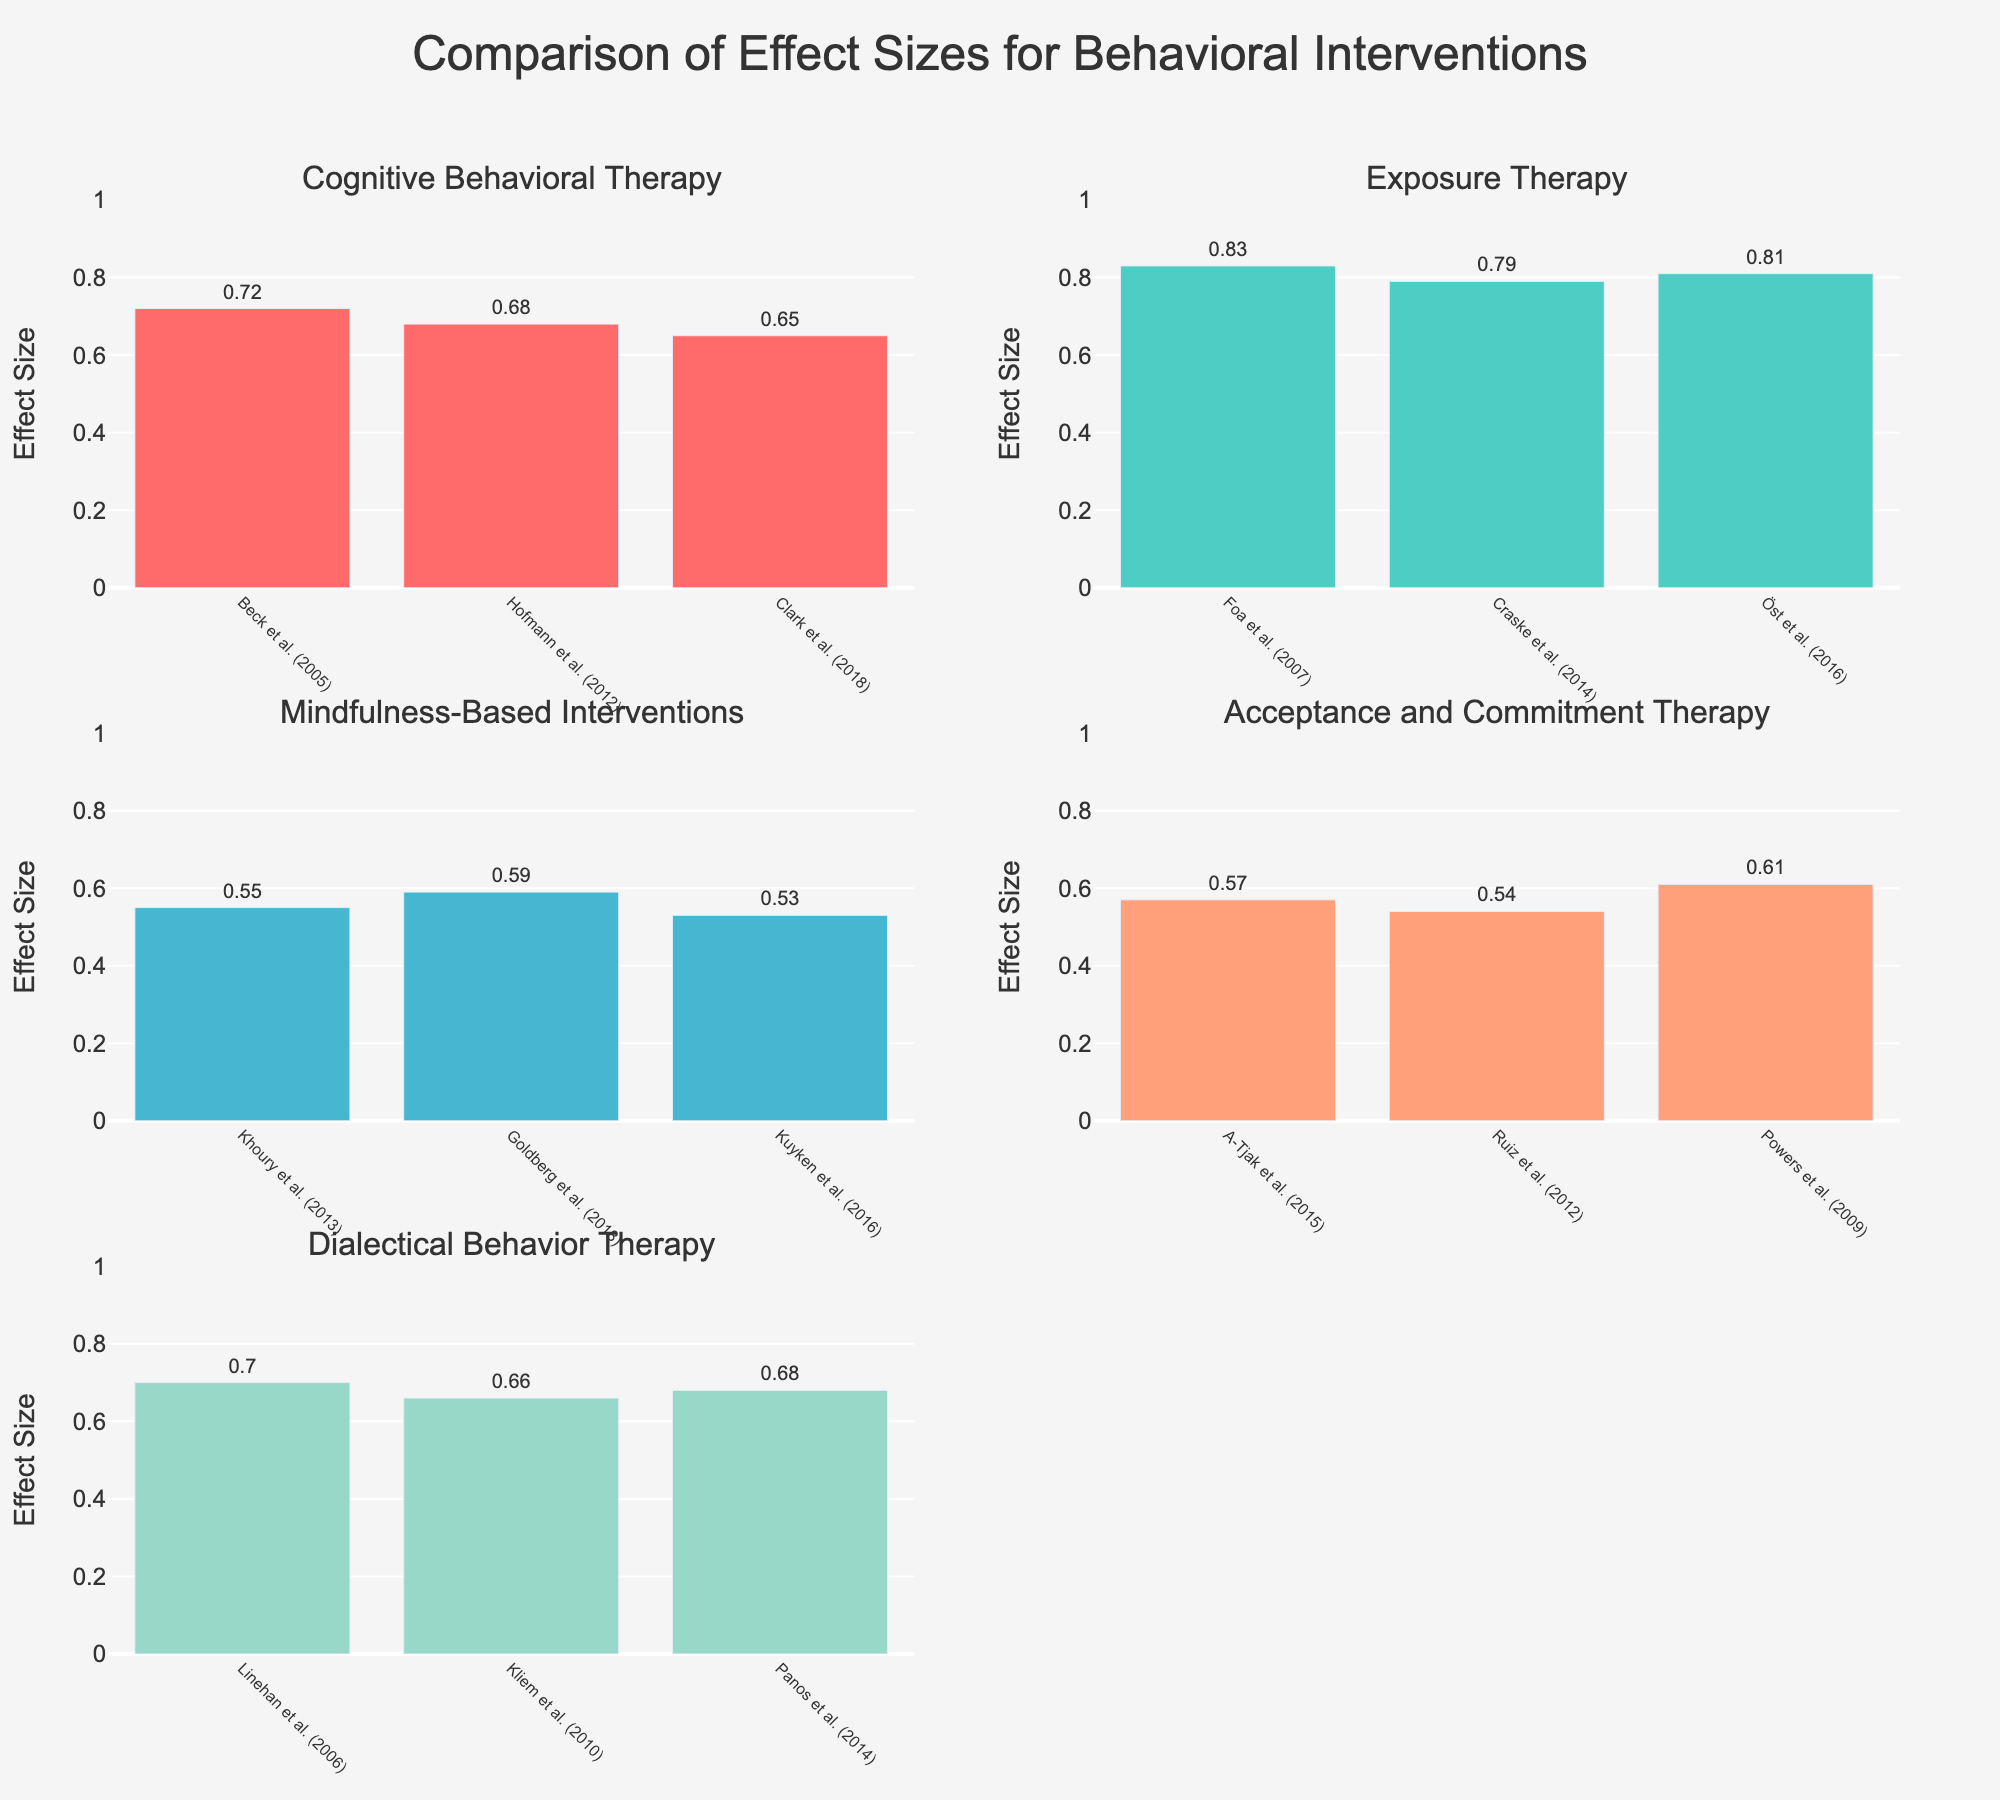How many behavioral interventions are compared in the figure? There are six unique behavioral interventions listed in the dataset. Each subplot corresponds to one of these interventions, as indicated by the titles of the subplots.
Answer: Six What is the range of effect sizes for Cognitive Behavioral Therapy? The effect sizes for Cognitive Behavioral Therapy are 0.72, 0.68, and 0.65. The range is the difference between the maximum and the minimum values, which is 0.72 - 0.65 = 0.07.
Answer: 0.07 Which intervention has the highest individual effect size, and what is its value? By examining the bars, the intervention with the highest individual effect size is Exposure Therapy by Foa et al. (2007) with an effect size of 0.83.
Answer: Exposure Therapy, 0.83 Compare the average effect sizes of Mindfulness-Based Interventions and Dialectical Behavior Therapy. Which one is higher? For Mindfulness-Based Interventions, the average effect size is (0.55 + 0.59 + 0.53) / 3 = 0.56. For Dialectical Behavior Therapy, the average effect size is (0.70 + 0.66 + 0.68) / 3 = 0.68. Dialectical Behavior Therapy has the higher average effect size.
Answer: Dialectical Behavior Therapy Which study for Acceptance and Commitment Therapy reported the highest effect size? The Acceptance and Commitment Therapy studies have effect sizes of 0.57, 0.54, and 0.61. The highest is 0.61, reported by Powers et al. (2009).
Answer: Powers et al. (2009) Identify the intervention with the smallest variability in effect sizes across studies. Variability can be inferred by looking at the range or how close the effect sizes are to each other. For Mindfulness-Based Interventions, the effect sizes are close to each other: 0.55, 0.59, and 0.53. The range is 0.59 - 0.53 = 0.06, which is smaller compared to other interventions.
Answer: Mindfulness-Based Interventions On which subplot do the bars represent the widest range of effect sizes? By observing the data, Cognitive Behavioral Therapy has effect sizes ranging from 0.72 to 0.65, resulting in a range of 0.07. Exposure Therapy has a range from 0.83 to 0.79 = 0.04. Acceptance and Commitment Therapy has a range from 0.61 to 0.54 = 0.07. Dialectical Behavior Therapy has a range from 0.70 to 0.66 = 0.04. Mindfulness-Based Interventions have a range from 0.59 to 0.53 = 0.06. Assuming the range 0.07, both Cognitive Behavioral Therapy and Acceptance and Commitment Therapy have the widest range.
Answer: Cognitive Behavioral Therapy and Acceptance and Commitment Therapy What is the overall trend shown for the effect sizes of Exposure Therapy? All effect sizes for Exposure Therapy (0.83, 0.79, 0.81) are relatively high and close to each other, showing a consistently strong effect across different studies.
Answer: Consistently high Which interventions have their effect sizes denoted with the color that appears most often in the figure? The colors unique to each intervention repeat across bars referring to studies on that intervention. The most frequently appearing color would belong to the intervention with the most studies (each intervention has three studies). Because all have equal frequency, Cognitive Behavioral Therapy, Exposure Therapy, Mindfulness-Based Interventions, and Dialectical Behavior Therapy are all correct answers.
Answer: Cognitive Behavioral Therapy, Exposure Therapy, Mindfulness-Based Interventions, and Dialectical Behavior Therapy 